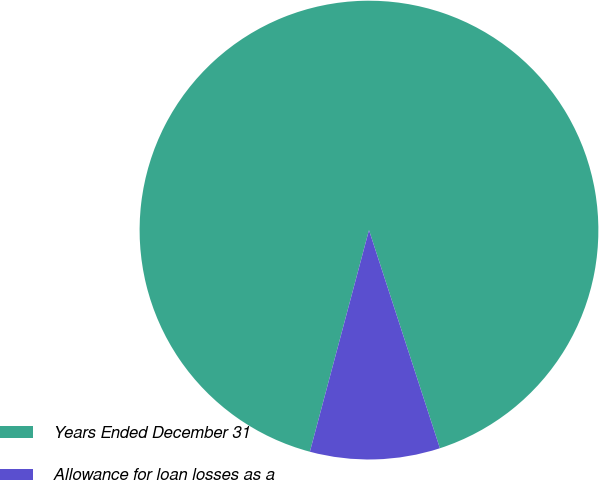Convert chart to OTSL. <chart><loc_0><loc_0><loc_500><loc_500><pie_chart><fcel>Years Ended December 31<fcel>Allowance for loan losses as a<nl><fcel>90.85%<fcel>9.15%<nl></chart> 